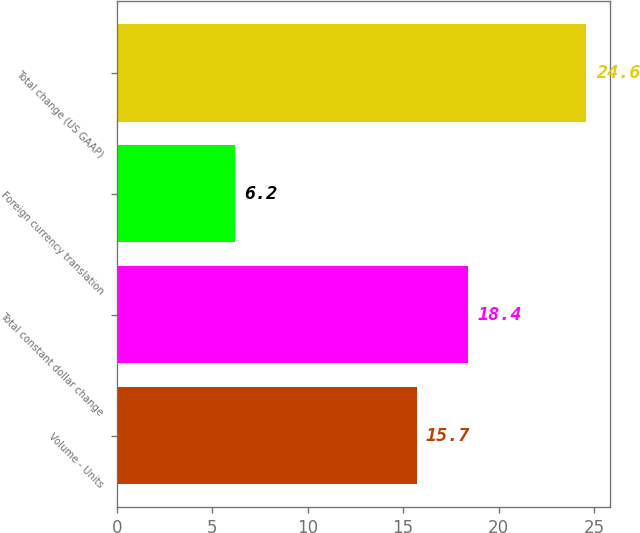Convert chart. <chart><loc_0><loc_0><loc_500><loc_500><bar_chart><fcel>Volume - Units<fcel>Total constant dollar change<fcel>Foreign currency translation<fcel>Total change (US GAAP)<nl><fcel>15.7<fcel>18.4<fcel>6.2<fcel>24.6<nl></chart> 